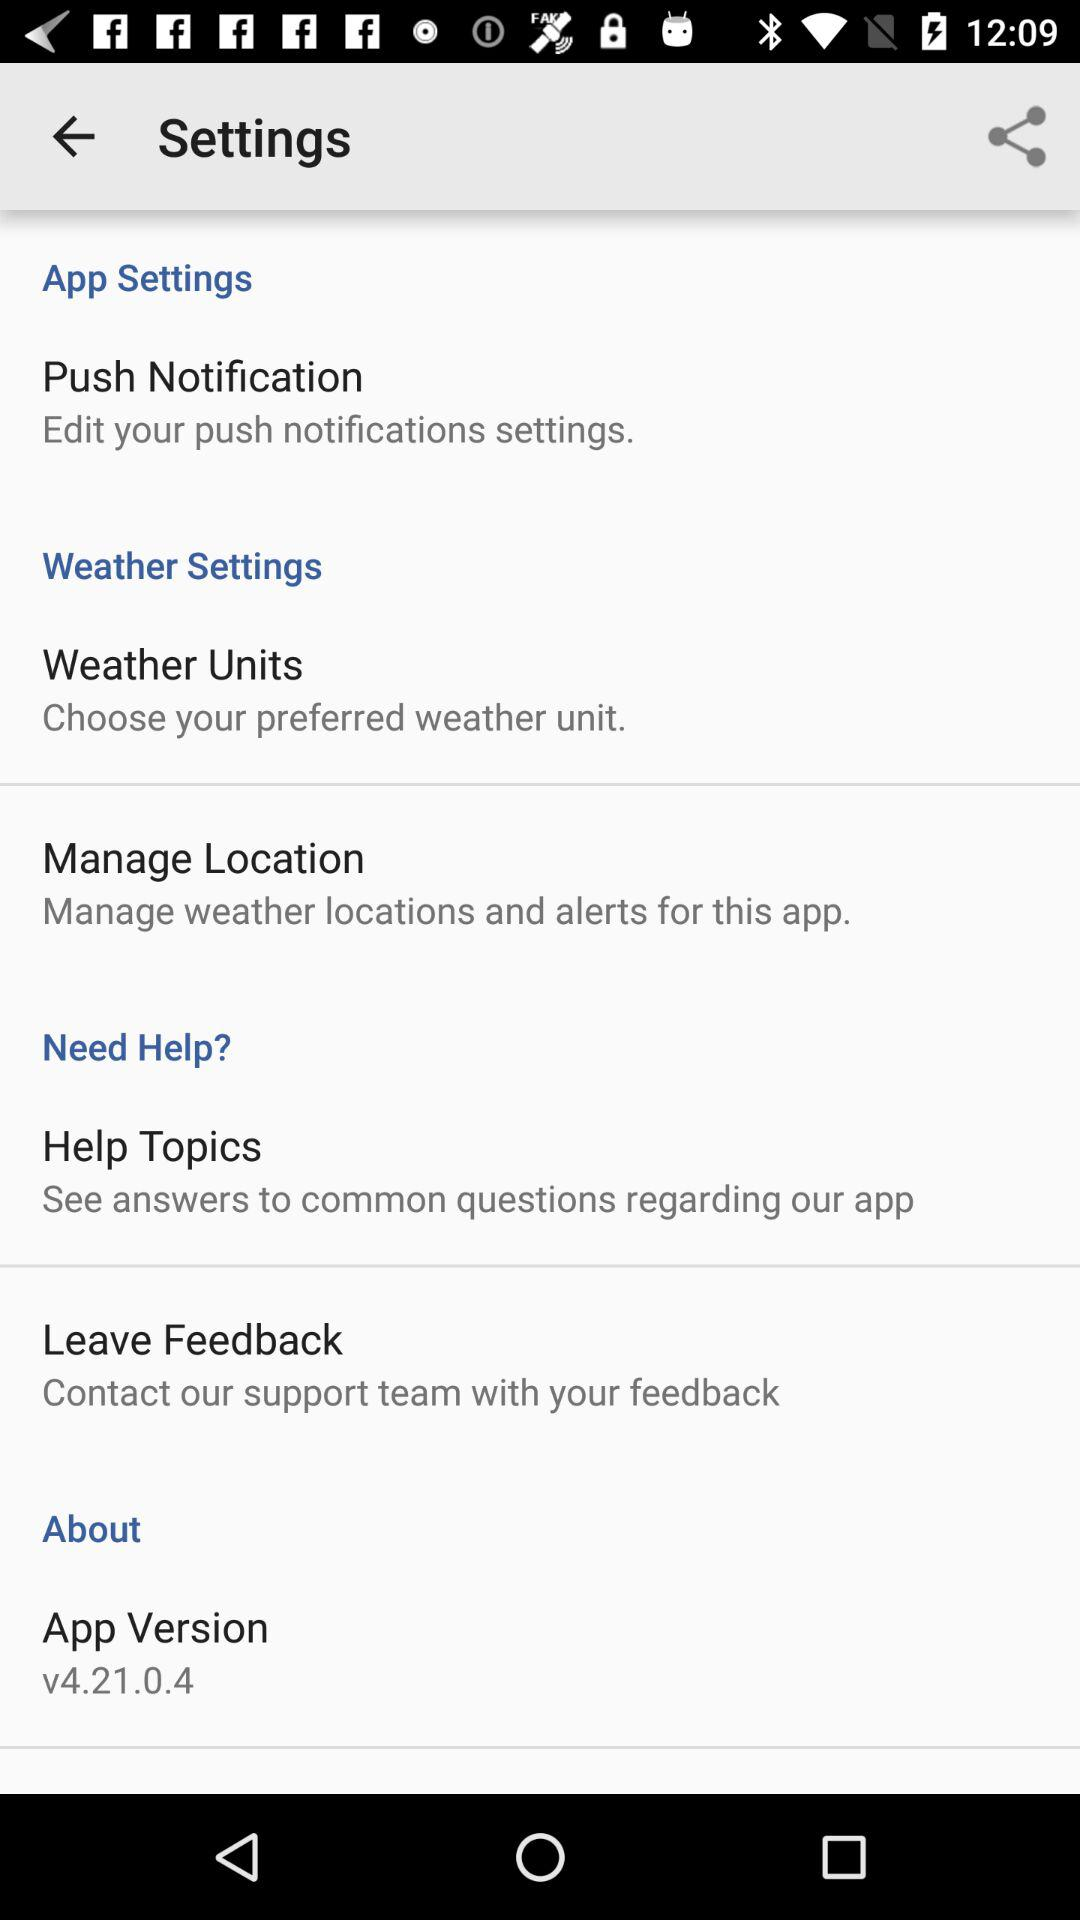Which is the version of the application? The version of the application is v4.21.0.4. 